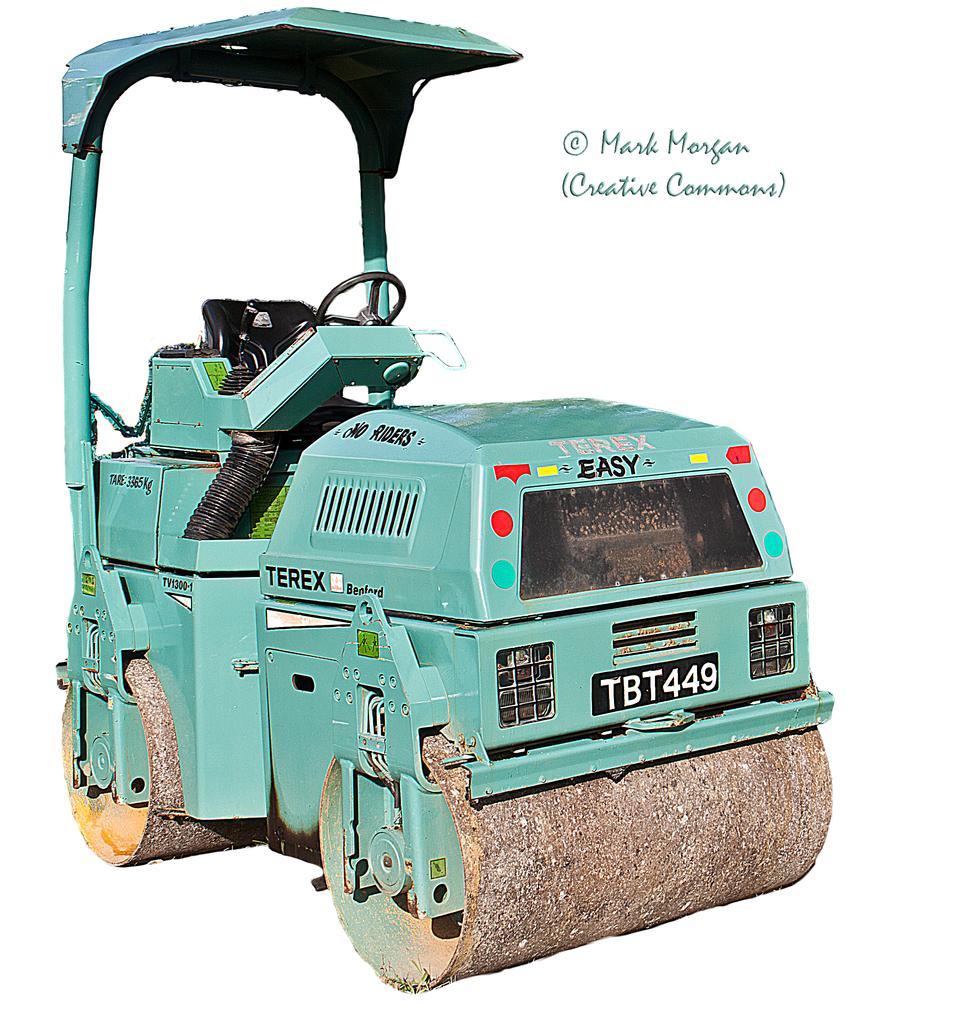How would you summarize this image in a sentence or two? In this image we can see a vehicle and we can also see the text. 